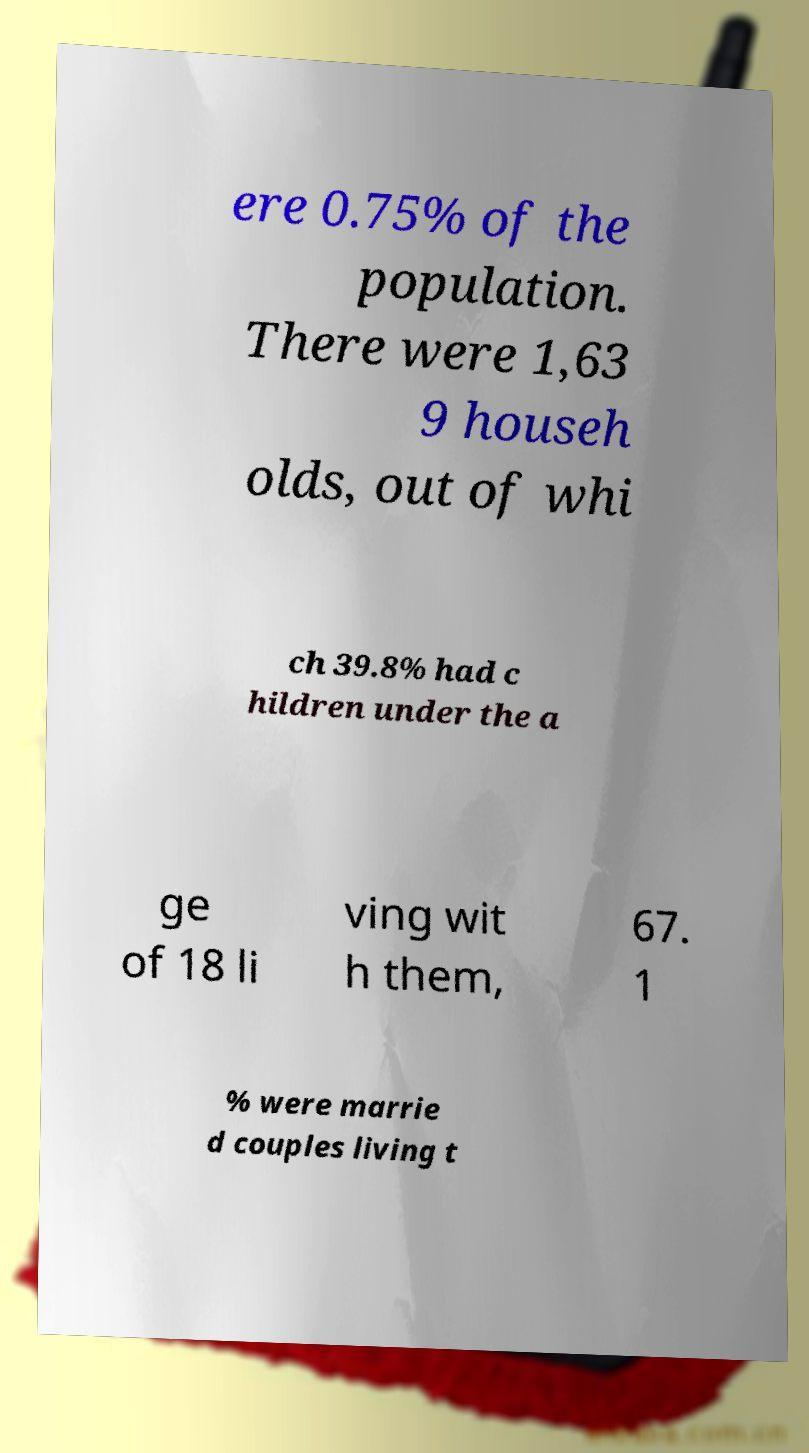Could you assist in decoding the text presented in this image and type it out clearly? ere 0.75% of the population. There were 1,63 9 househ olds, out of whi ch 39.8% had c hildren under the a ge of 18 li ving wit h them, 67. 1 % were marrie d couples living t 